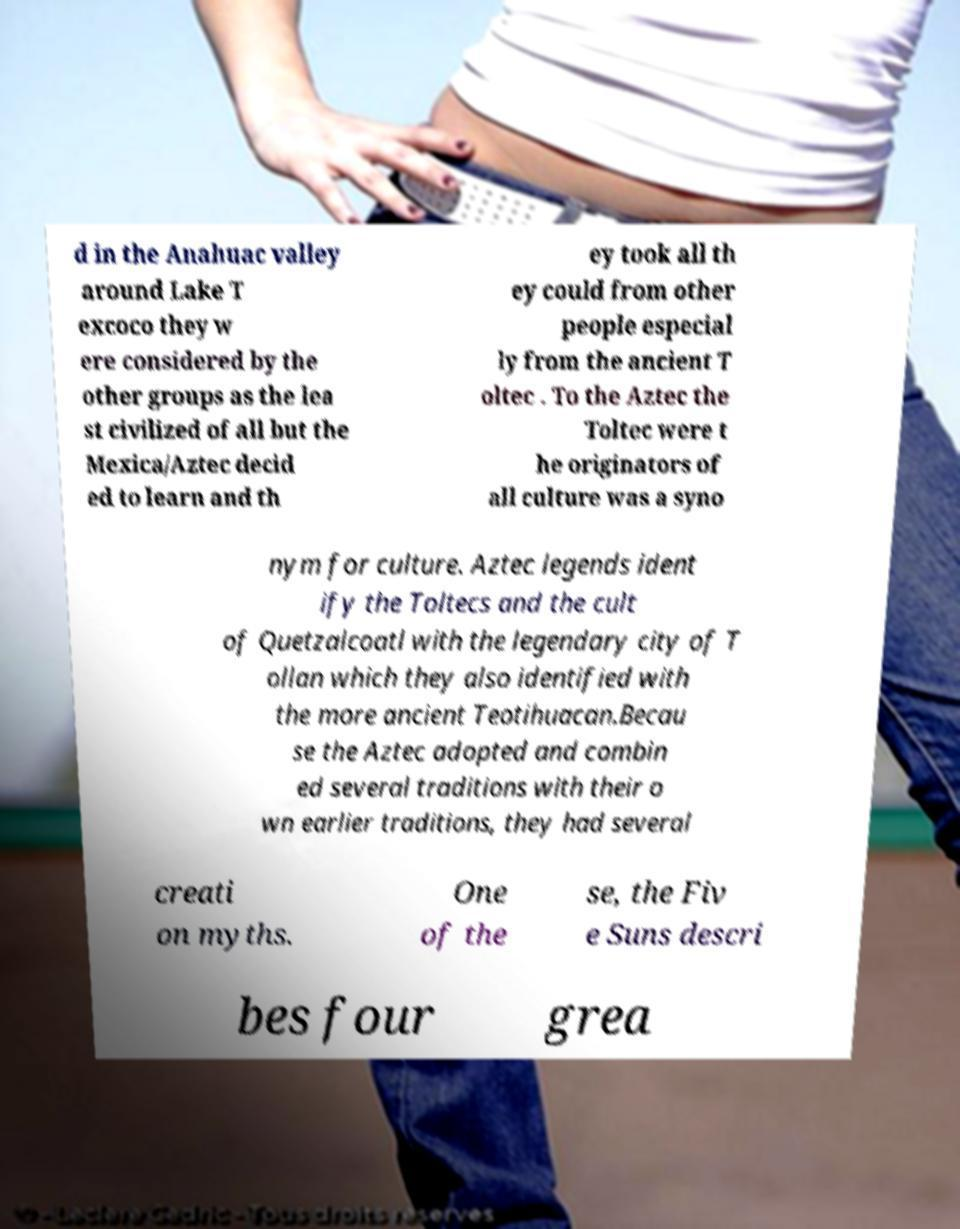Please identify and transcribe the text found in this image. d in the Anahuac valley around Lake T excoco they w ere considered by the other groups as the lea st civilized of all but the Mexica/Aztec decid ed to learn and th ey took all th ey could from other people especial ly from the ancient T oltec . To the Aztec the Toltec were t he originators of all culture was a syno nym for culture. Aztec legends ident ify the Toltecs and the cult of Quetzalcoatl with the legendary city of T ollan which they also identified with the more ancient Teotihuacan.Becau se the Aztec adopted and combin ed several traditions with their o wn earlier traditions, they had several creati on myths. One of the se, the Fiv e Suns descri bes four grea 